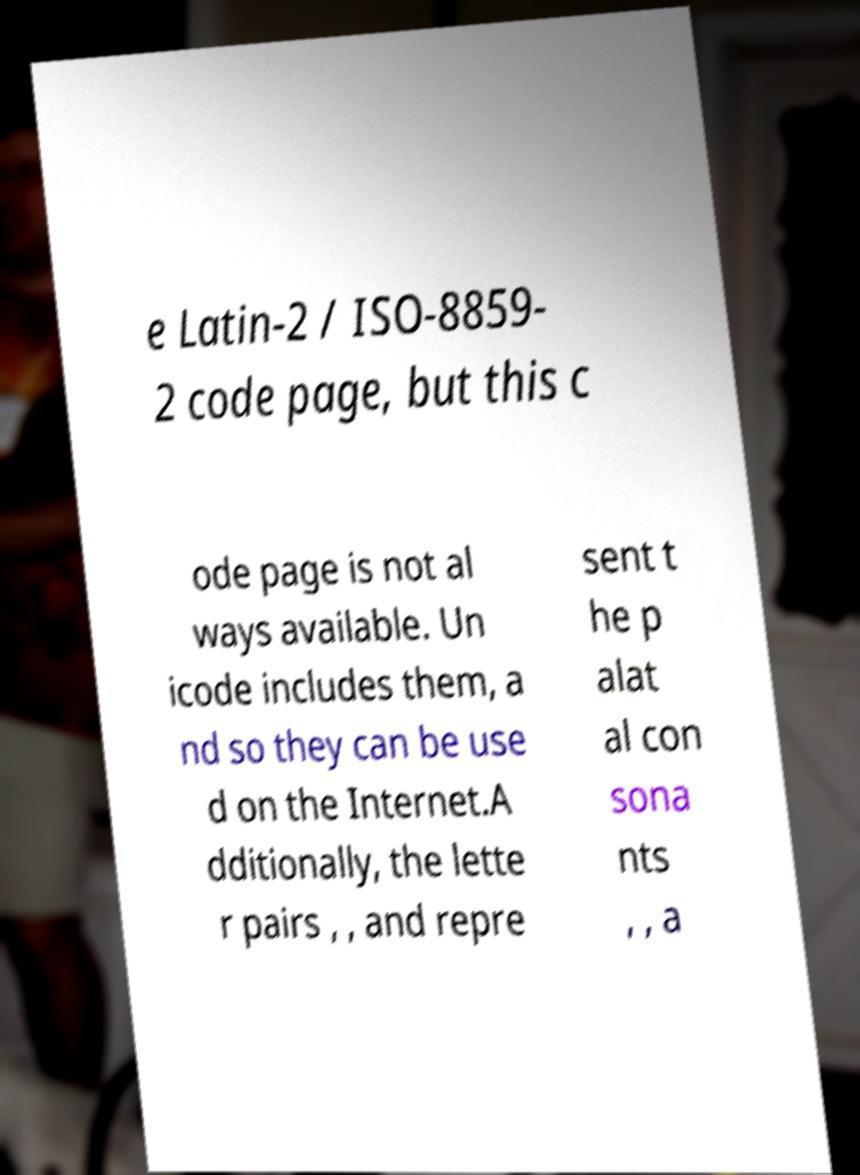Can you accurately transcribe the text from the provided image for me? e Latin-2 / ISO-8859- 2 code page, but this c ode page is not al ways available. Un icode includes them, a nd so they can be use d on the Internet.A dditionally, the lette r pairs , , and repre sent t he p alat al con sona nts , , a 